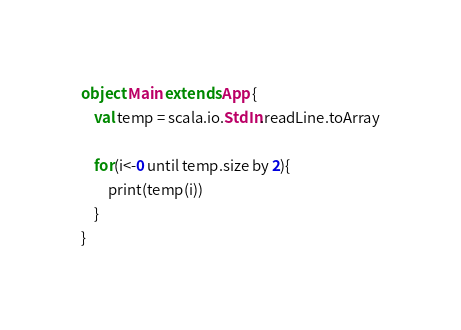<code> <loc_0><loc_0><loc_500><loc_500><_Scala_>object Main extends App {
	val temp = scala.io.StdIn.readLine.toArray

	for(i<-0 until temp.size by 2){
		print(temp(i))
	}
}
</code> 